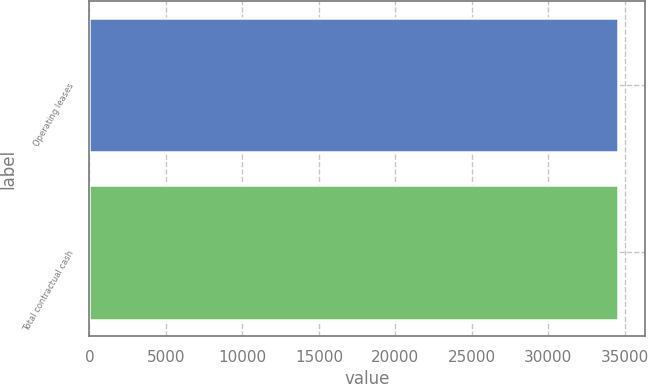Convert chart. <chart><loc_0><loc_0><loc_500><loc_500><bar_chart><fcel>Operating leases<fcel>Total contractual cash<nl><fcel>34556<fcel>34556.1<nl></chart> 